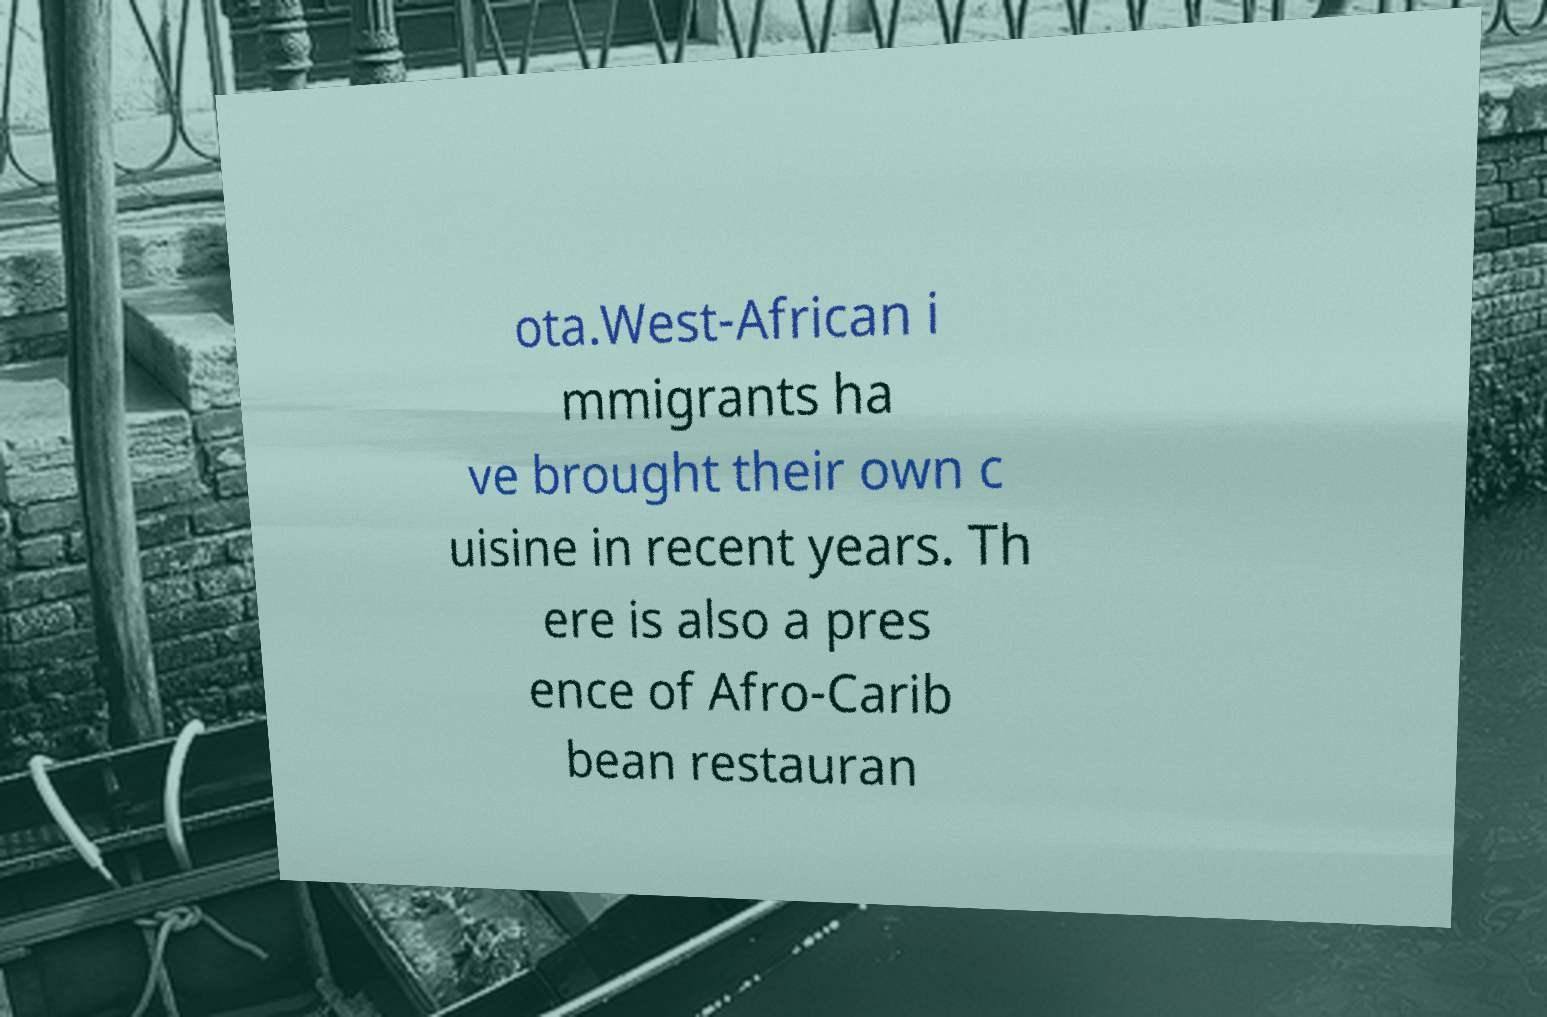Can you accurately transcribe the text from the provided image for me? ota.West-African i mmigrants ha ve brought their own c uisine in recent years. Th ere is also a pres ence of Afro-Carib bean restauran 